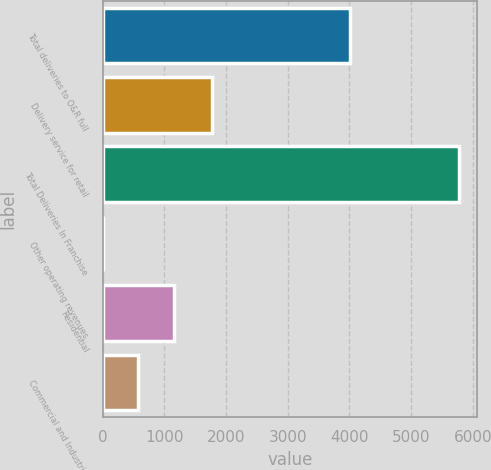Convert chart. <chart><loc_0><loc_0><loc_500><loc_500><bar_chart><fcel>Total deliveries to O&R full<fcel>Delivery service for retail<fcel>Total Deliveries In Franchise<fcel>Other operating revenues<fcel>Residential<fcel>Commercial and Industrial<nl><fcel>4010<fcel>1766<fcel>5776<fcel>3<fcel>1157.6<fcel>580.3<nl></chart> 